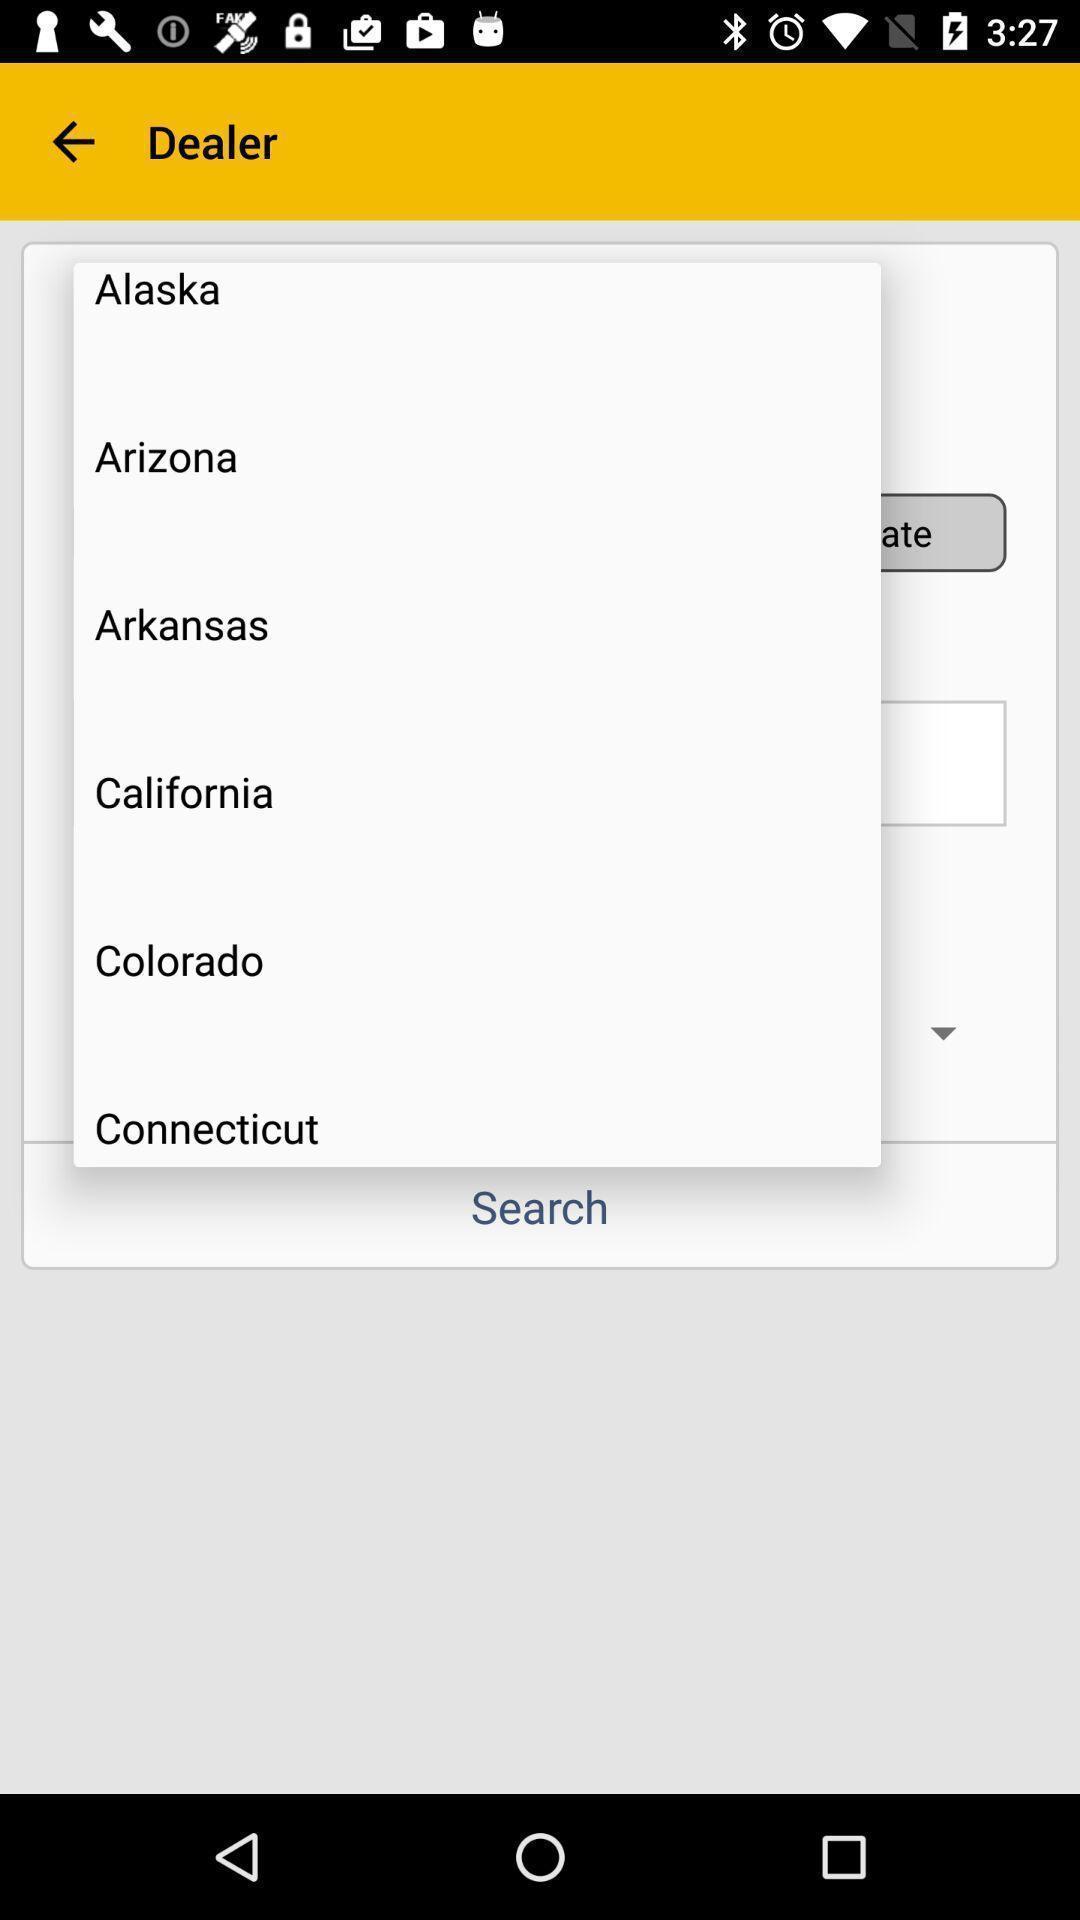What can you discern from this picture? Popup page for selecting a particular location. 